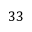Convert formula to latex. <formula><loc_0><loc_0><loc_500><loc_500>3 3</formula> 